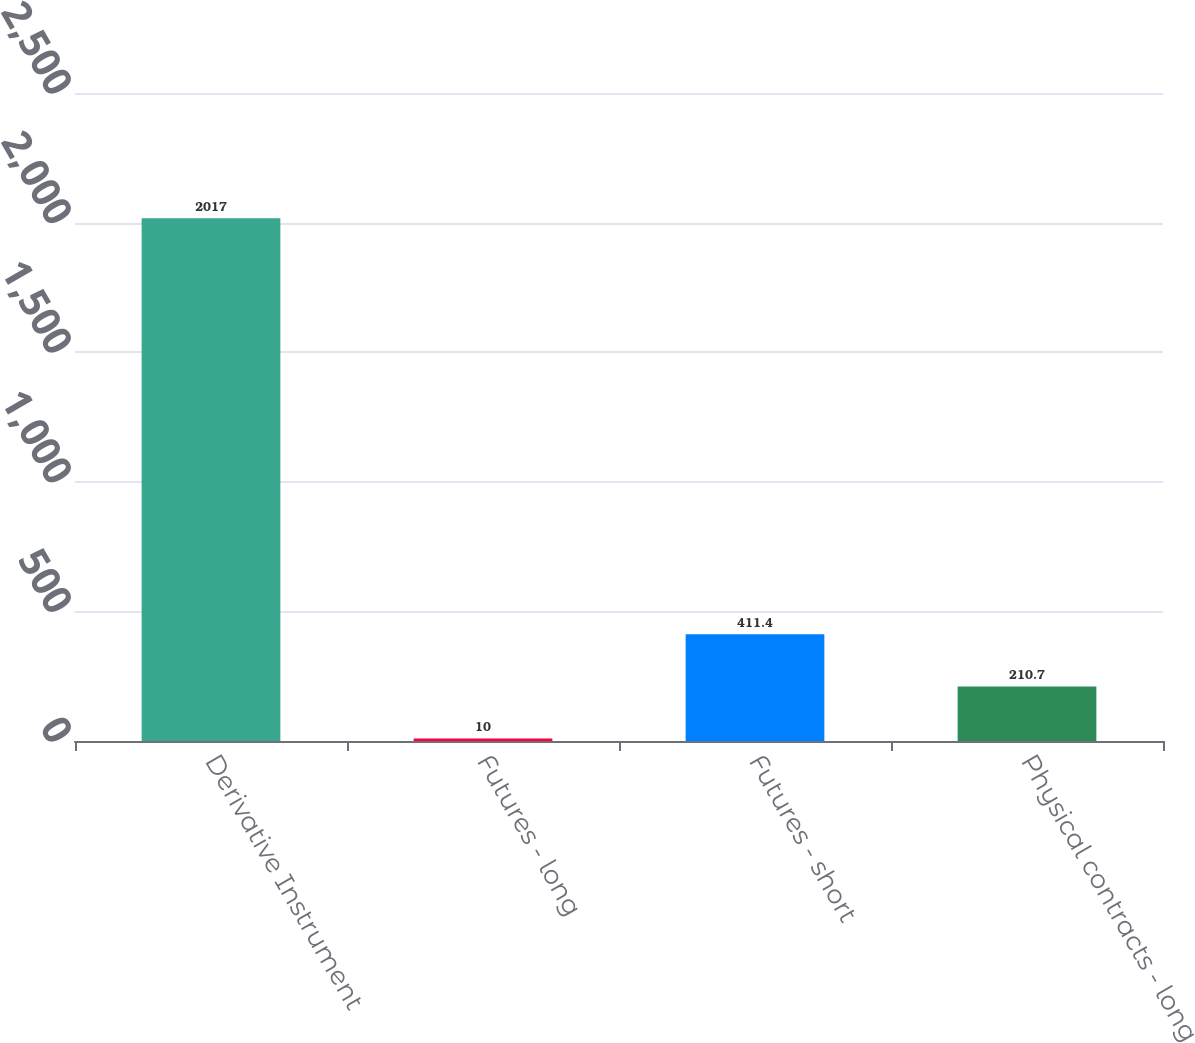Convert chart to OTSL. <chart><loc_0><loc_0><loc_500><loc_500><bar_chart><fcel>Derivative Instrument<fcel>Futures - long<fcel>Futures - short<fcel>Physical contracts - long<nl><fcel>2017<fcel>10<fcel>411.4<fcel>210.7<nl></chart> 